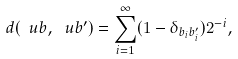Convert formula to latex. <formula><loc_0><loc_0><loc_500><loc_500>d ( \ u b , \ u b ^ { \prime } ) = \sum _ { i = 1 } ^ { \infty } ( 1 - \delta _ { b _ { i } b ^ { \prime } _ { i } } ) 2 ^ { - i } ,</formula> 